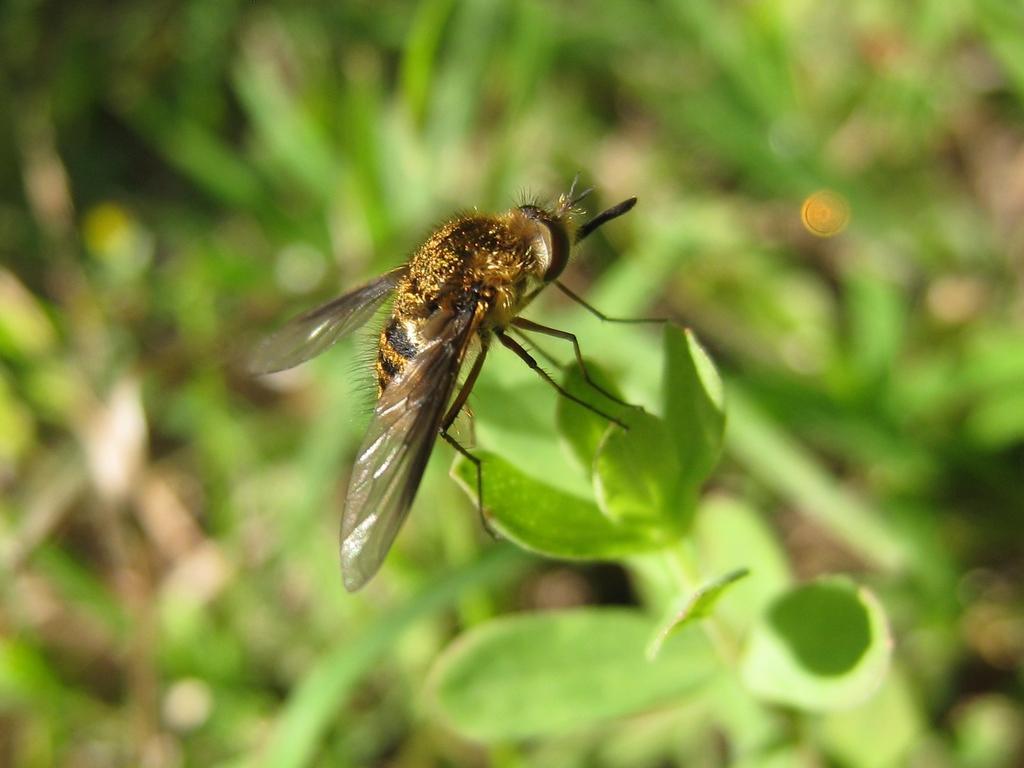Describe this image in one or two sentences. In the center of the image, we can see a honey bee on the leaf and in the background, there are leaves. 